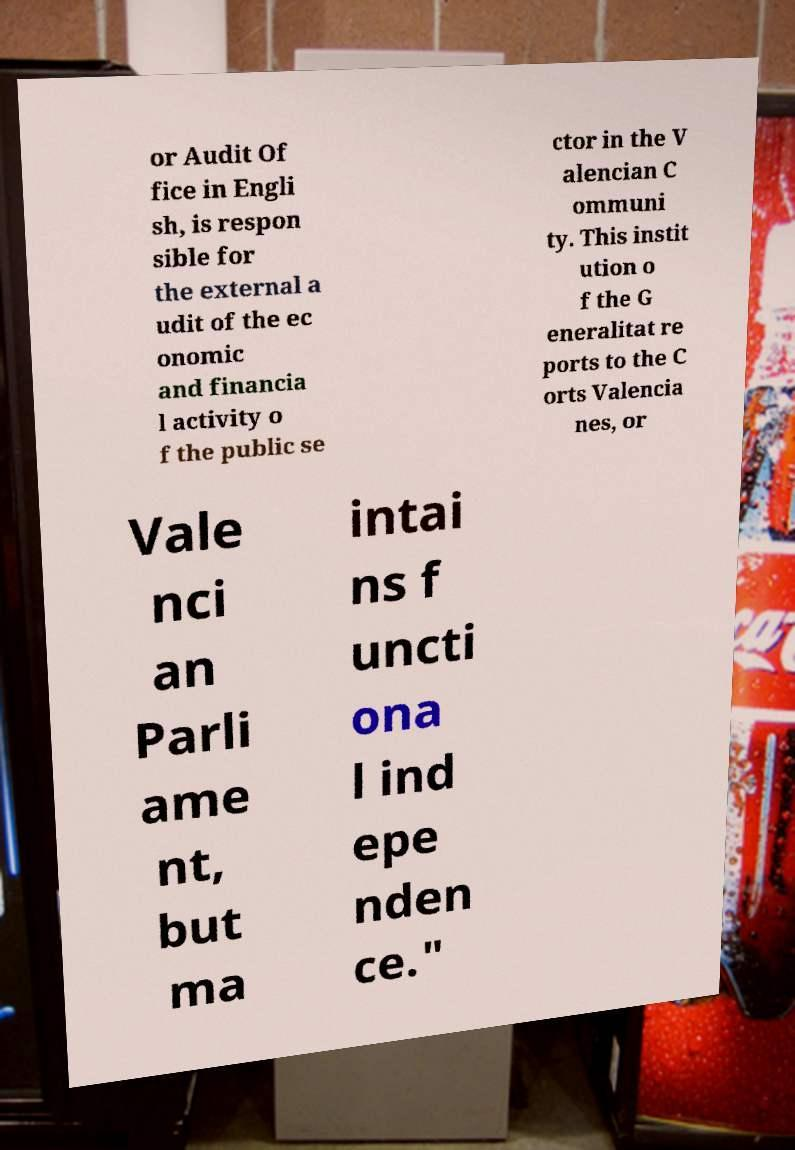Please identify and transcribe the text found in this image. or Audit Of fice in Engli sh, is respon sible for the external a udit of the ec onomic and financia l activity o f the public se ctor in the V alencian C ommuni ty. This instit ution o f the G eneralitat re ports to the C orts Valencia nes, or Vale nci an Parli ame nt, but ma intai ns f uncti ona l ind epe nden ce." 